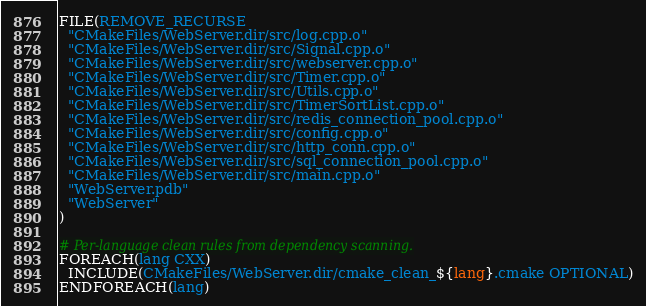<code> <loc_0><loc_0><loc_500><loc_500><_CMake_>FILE(REMOVE_RECURSE
  "CMakeFiles/WebServer.dir/src/log.cpp.o"
  "CMakeFiles/WebServer.dir/src/Signal.cpp.o"
  "CMakeFiles/WebServer.dir/src/webserver.cpp.o"
  "CMakeFiles/WebServer.dir/src/Timer.cpp.o"
  "CMakeFiles/WebServer.dir/src/Utils.cpp.o"
  "CMakeFiles/WebServer.dir/src/TimerSortList.cpp.o"
  "CMakeFiles/WebServer.dir/src/redis_connection_pool.cpp.o"
  "CMakeFiles/WebServer.dir/src/config.cpp.o"
  "CMakeFiles/WebServer.dir/src/http_conn.cpp.o"
  "CMakeFiles/WebServer.dir/src/sql_connection_pool.cpp.o"
  "CMakeFiles/WebServer.dir/src/main.cpp.o"
  "WebServer.pdb"
  "WebServer"
)

# Per-language clean rules from dependency scanning.
FOREACH(lang CXX)
  INCLUDE(CMakeFiles/WebServer.dir/cmake_clean_${lang}.cmake OPTIONAL)
ENDFOREACH(lang)
</code> 